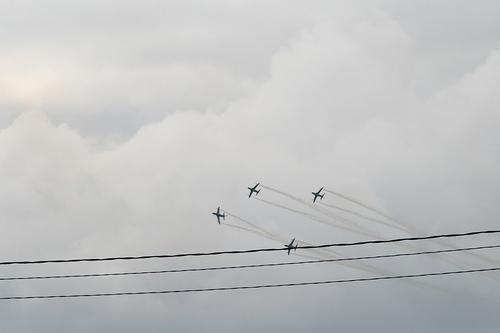How many power cables are shown?
Give a very brief answer. 3. How many jets are in formation?
Give a very brief answer. 4. How many wires are shown?
Give a very brief answer. 3. 